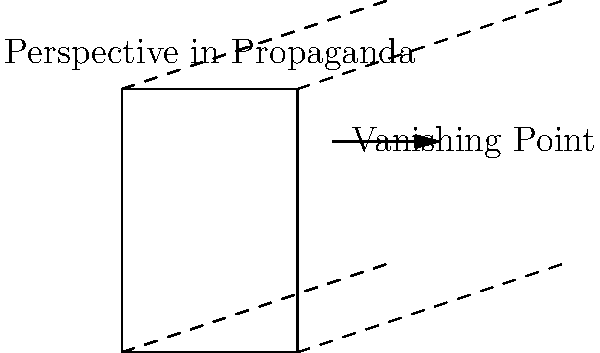Analyze the use of perspective in this simplified representation of a propaganda poster from a major 20th-century conflict. How does the application of linear perspective contribute to the poster's emotional impact and message delivery? Consider the historical context and the documentarian's interpretation of such visual techniques in your response. To answer this question, we need to consider several aspects of perspective use in propaganda posters:

1. Linear Perspective: The diagram shows converging lines that create a sense of depth and draw the viewer's eye to a specific point. This technique was often used in 20th-century propaganda posters to:
   a) Create a sense of grandeur and scale
   b) Direct attention to key elements or messages

2. Historical Context: During major 20th-century conflicts (e.g., World Wars, Cold War), propaganda posters were crucial tools for:
   a) Mobilizing public support
   b) Boosting morale
   c) Demonizing the enemy

3. Emotional Impact: The use of perspective in propaganda posters could:
   a) Create a sense of urgency or importance
   b) Evoke feelings of patriotism or fear
   c) Make the viewer feel small or large, depending on the intended message

4. Message Delivery: Perspective could be used to:
   a) Emphasize certain elements of the poster
   b) Create visual hierarchies of information
   c) Guide the viewer's eye through the poster's narrative

5. Documentarian's Interpretation: A documentarian might analyze this use of perspective as:
   a) A manipulation technique to influence viewers' emotions and perceptions
   b) A reflection of the artistic and cultural trends of the time
   c) An indicator of the sophistication of propaganda techniques during the period

The use of linear perspective in this simplified poster representation demonstrates how visual techniques were employed to enhance the emotional impact and effectiveness of propaganda messages. By creating depth and guiding the viewer's gaze, perspective became a powerful tool in shaping public opinion during major 20th-century conflicts.
Answer: Linear perspective in propaganda posters enhanced emotional impact and message delivery by creating depth, guiding viewer attention, and manipulating perception, reflecting sophisticated visual techniques used to shape public opinion during 20th-century conflicts. 